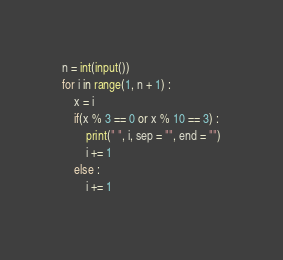<code> <loc_0><loc_0><loc_500><loc_500><_Python_>n = int(input())
for i in range(1, n + 1) :
	x = i
	if(x % 3 == 0 or x % 10 == 3) :
		print(" ", i, sep = "", end = "")
		i += 1
	else :
		i += 1

</code> 